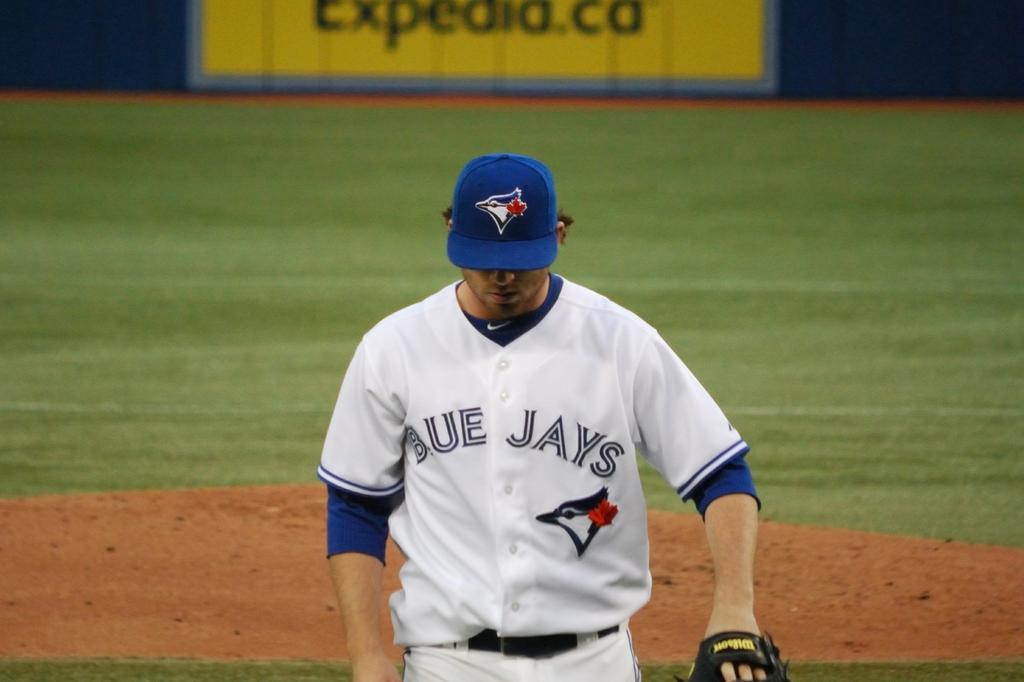What is the name of the team?
Give a very brief answer. Blue jays. 